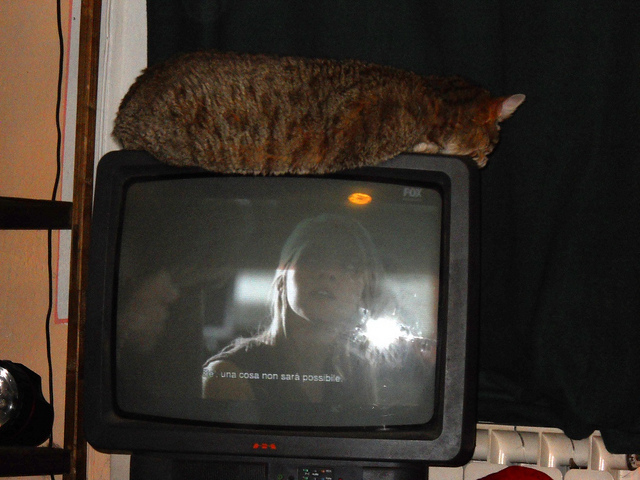Extract all visible text content from this image. una POSSIBLE Sara FOX non COSA 